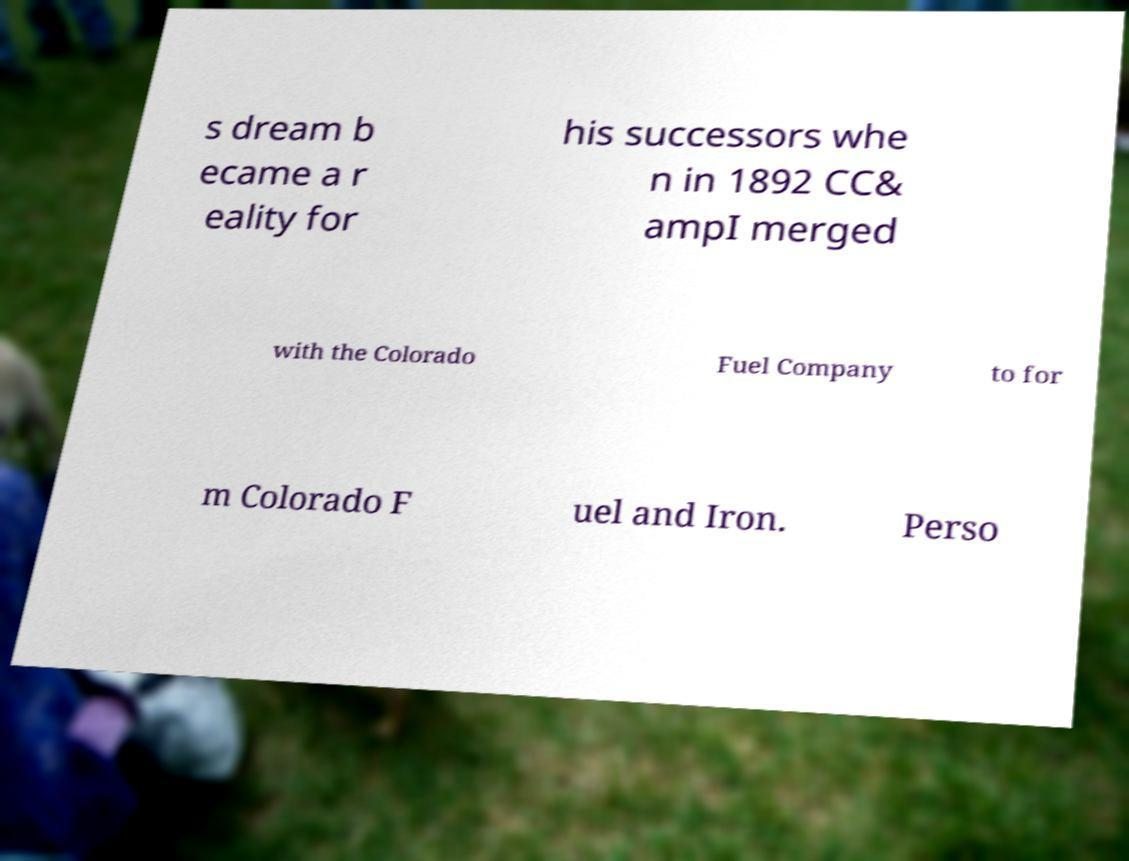I need the written content from this picture converted into text. Can you do that? s dream b ecame a r eality for his successors whe n in 1892 CC& ampI merged with the Colorado Fuel Company to for m Colorado F uel and Iron. Perso 